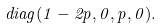Convert formula to latex. <formula><loc_0><loc_0><loc_500><loc_500>d i a g ( 1 - 2 p , 0 , p , 0 ) .</formula> 